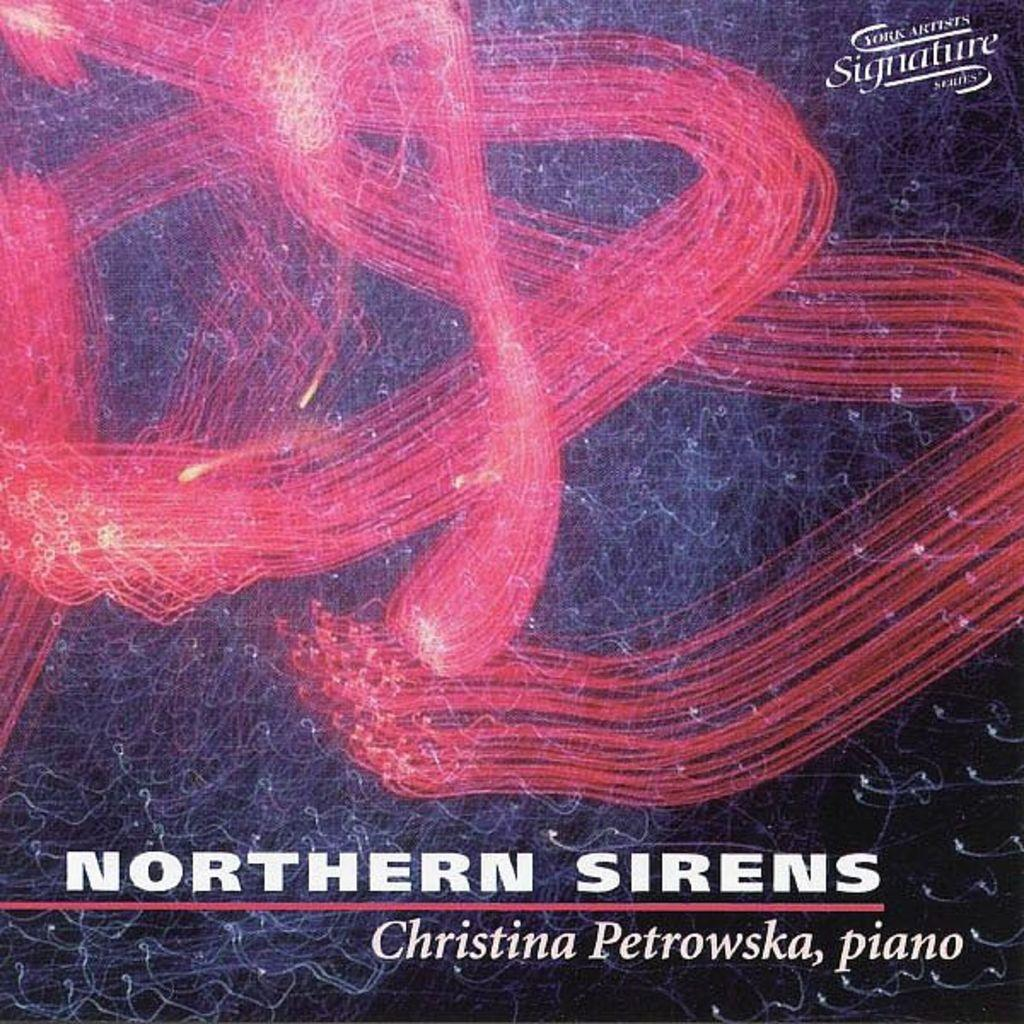<image>
Give a short and clear explanation of the subsequent image. An album cover of Christina Petrowska playing piano. 